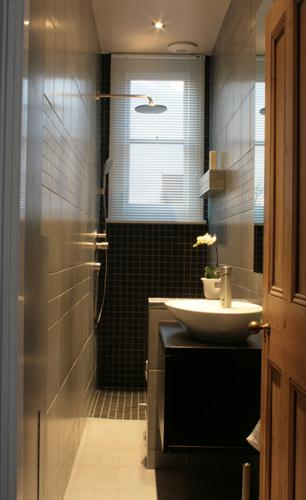Question: how many flowers are shown?
Choices:
A. Six.
B. One.
C. Twelve.
D. Thirteen.
Answer with the letter. Answer: B Question: what color is the flower?
Choices:
A. Pink.
B. Purple.
C. Yellow.
D. Red.
Answer with the letter. Answer: C Question: where is the door knob located?
Choices:
A. On the door.
B. On the window.
C. On the kitchen stove.
D. On the very old tv set.
Answer with the letter. Answer: A Question: where is the mirror located?
Choices:
A. On the bathroom wall.
B. At right side of the image.
C. Above the sink.
D. In the dressing room.
Answer with the letter. Answer: C 